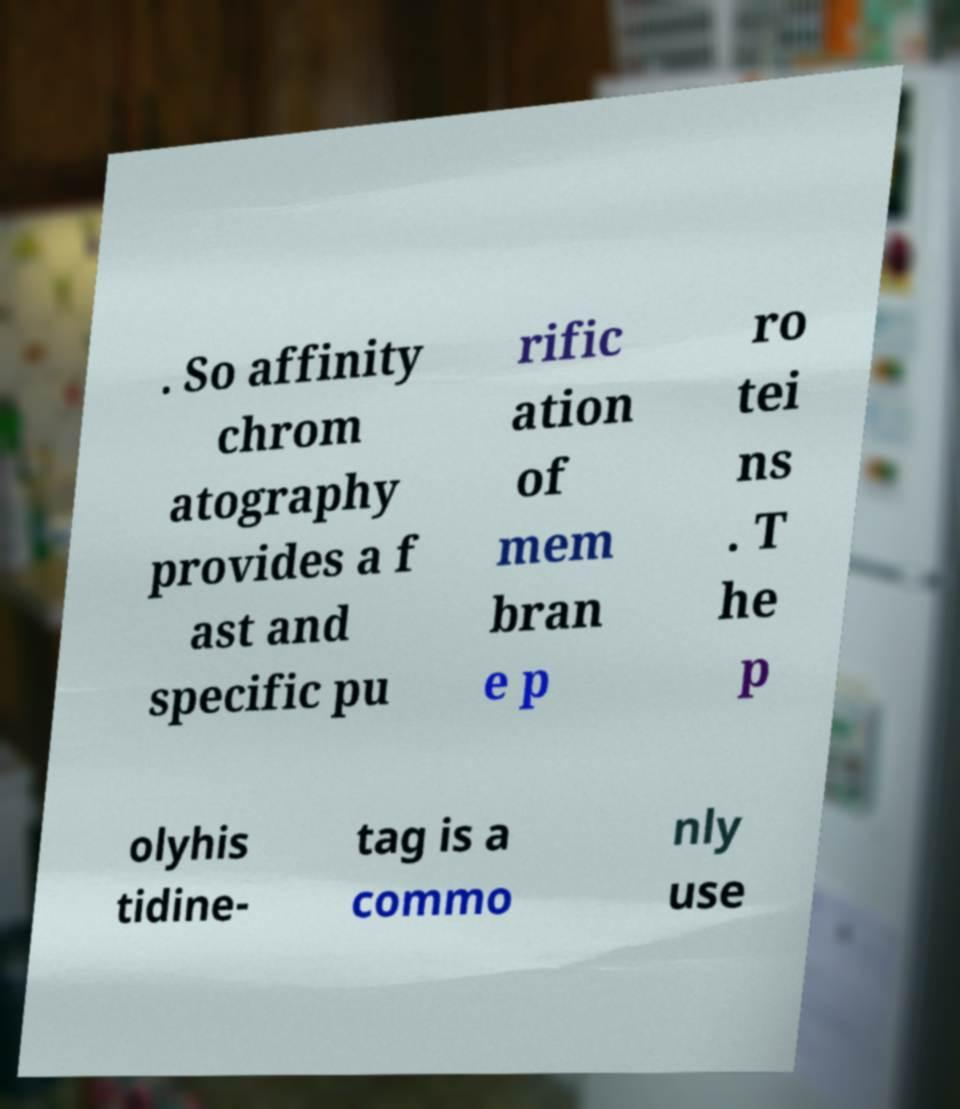Can you read and provide the text displayed in the image?This photo seems to have some interesting text. Can you extract and type it out for me? . So affinity chrom atography provides a f ast and specific pu rific ation of mem bran e p ro tei ns . T he p olyhis tidine- tag is a commo nly use 